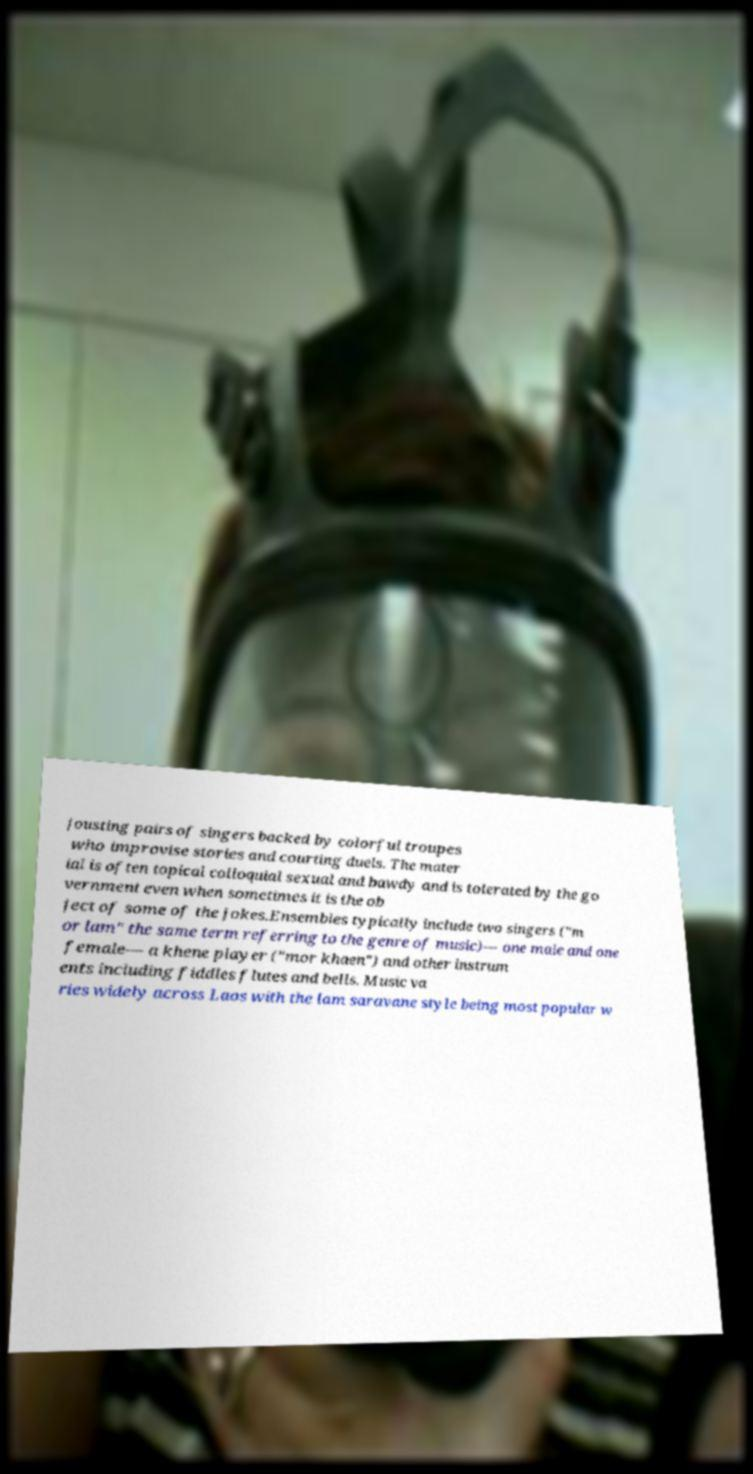For documentation purposes, I need the text within this image transcribed. Could you provide that? jousting pairs of singers backed by colorful troupes who improvise stories and courting duels. The mater ial is often topical colloquial sexual and bawdy and is tolerated by the go vernment even when sometimes it is the ob ject of some of the jokes.Ensembles typically include two singers ("m or lam" the same term referring to the genre of music)— one male and one female— a khene player ("mor khaen") and other instrum ents including fiddles flutes and bells. Music va ries widely across Laos with the lam saravane style being most popular w 